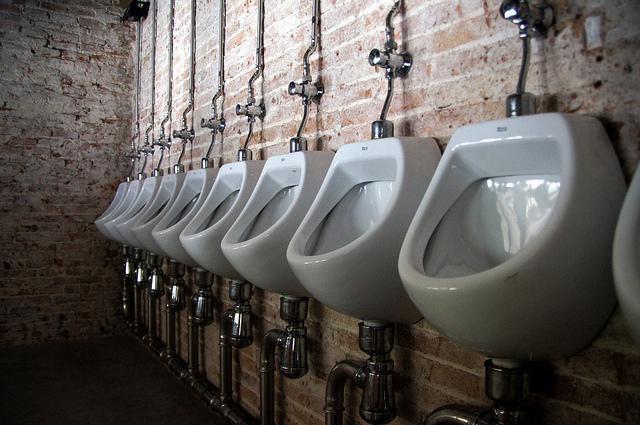What are these white objects used to hold?
Pick the correct solution from the four options below to address the question.
Options: Popcorn, urine, cats, bread. Urine. 